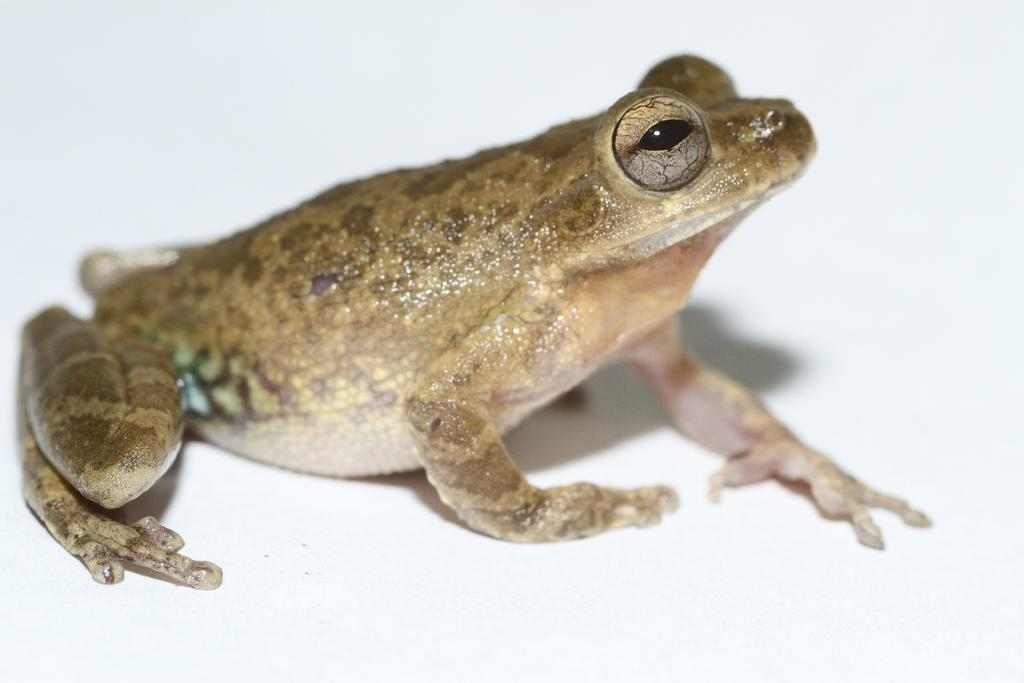What animal is present in the image? There is a frog in the image. What color is the background of the image? The background of the image is white. Can you tell me how many flowers are in the image? There are no flowers present in the image; it only features a frog against a white background. 